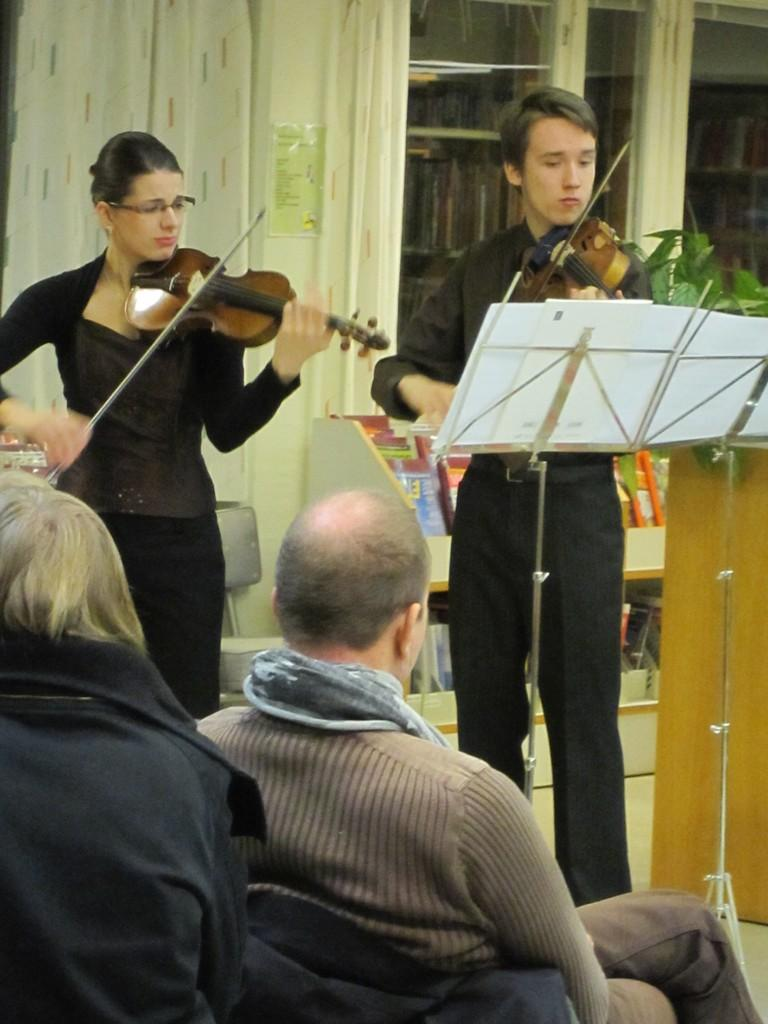How many people are present in the image? There are two people standing in the image. What are the standing people holding in their hands? The standing people are holding violins in their hands. What are the sitting people doing in the image? The sitting people are looking at the standing people. Can you describe the interaction between the standing and sitting people? The standing people appear to be performing or teaching, while the sitting people are observing or learning. What type of sail can be seen in the image? There is no sail present in the image. How many goldfish are swimming in the violin cases? There are no goldfish or violin cases present in the image. 